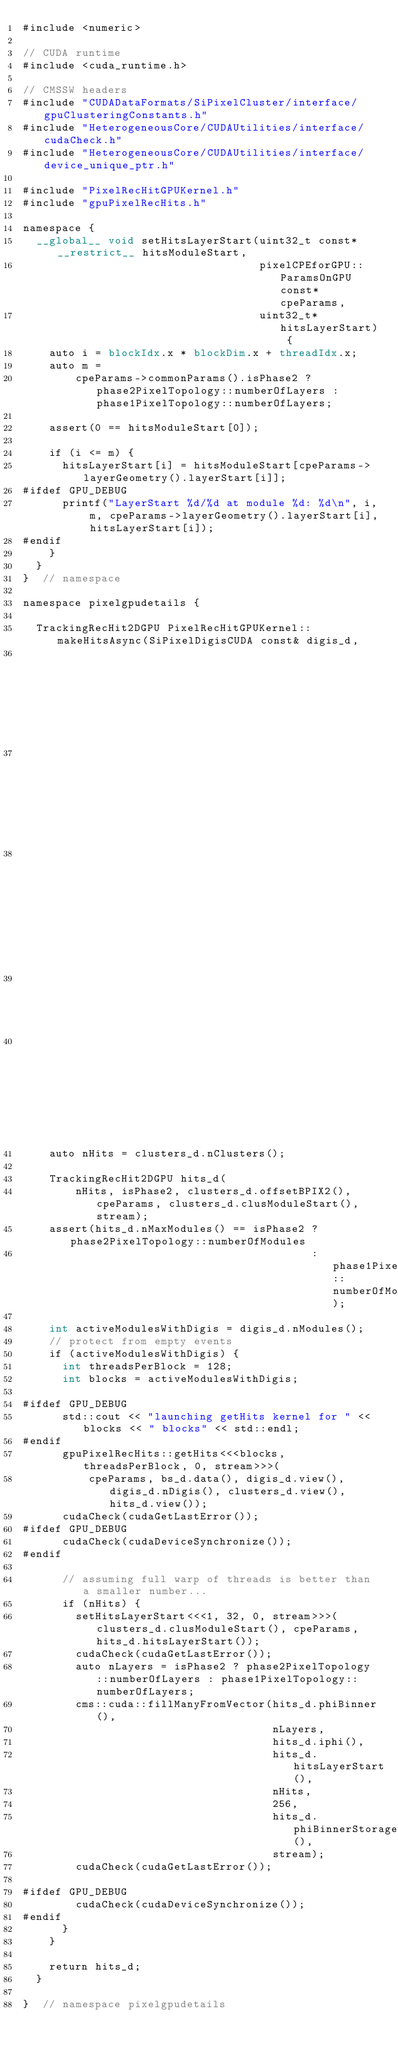<code> <loc_0><loc_0><loc_500><loc_500><_Cuda_>#include <numeric>

// CUDA runtime
#include <cuda_runtime.h>

// CMSSW headers
#include "CUDADataFormats/SiPixelCluster/interface/gpuClusteringConstants.h"
#include "HeterogeneousCore/CUDAUtilities/interface/cudaCheck.h"
#include "HeterogeneousCore/CUDAUtilities/interface/device_unique_ptr.h"

#include "PixelRecHitGPUKernel.h"
#include "gpuPixelRecHits.h"

namespace {
  __global__ void setHitsLayerStart(uint32_t const* __restrict__ hitsModuleStart,
                                    pixelCPEforGPU::ParamsOnGPU const* cpeParams,
                                    uint32_t* hitsLayerStart) {
    auto i = blockIdx.x * blockDim.x + threadIdx.x;
    auto m =
        cpeParams->commonParams().isPhase2 ? phase2PixelTopology::numberOfLayers : phase1PixelTopology::numberOfLayers;

    assert(0 == hitsModuleStart[0]);

    if (i <= m) {
      hitsLayerStart[i] = hitsModuleStart[cpeParams->layerGeometry().layerStart[i]];
#ifdef GPU_DEBUG
      printf("LayerStart %d/%d at module %d: %d\n", i, m, cpeParams->layerGeometry().layerStart[i], hitsLayerStart[i]);
#endif
    }
  }
}  // namespace

namespace pixelgpudetails {

  TrackingRecHit2DGPU PixelRecHitGPUKernel::makeHitsAsync(SiPixelDigisCUDA const& digis_d,
                                                          SiPixelClustersCUDA const& clusters_d,
                                                          BeamSpotCUDA const& bs_d,
                                                          pixelCPEforGPU::ParamsOnGPU const* cpeParams,
                                                          bool isPhase2,
                                                          cudaStream_t stream) const {
    auto nHits = clusters_d.nClusters();

    TrackingRecHit2DGPU hits_d(
        nHits, isPhase2, clusters_d.offsetBPIX2(), cpeParams, clusters_d.clusModuleStart(), stream);
    assert(hits_d.nMaxModules() == isPhase2 ? phase2PixelTopology::numberOfModules
                                            : phase1PixelTopology::numberOfModules);

    int activeModulesWithDigis = digis_d.nModules();
    // protect from empty events
    if (activeModulesWithDigis) {
      int threadsPerBlock = 128;
      int blocks = activeModulesWithDigis;

#ifdef GPU_DEBUG
      std::cout << "launching getHits kernel for " << blocks << " blocks" << std::endl;
#endif
      gpuPixelRecHits::getHits<<<blocks, threadsPerBlock, 0, stream>>>(
          cpeParams, bs_d.data(), digis_d.view(), digis_d.nDigis(), clusters_d.view(), hits_d.view());
      cudaCheck(cudaGetLastError());
#ifdef GPU_DEBUG
      cudaCheck(cudaDeviceSynchronize());
#endif

      // assuming full warp of threads is better than a smaller number...
      if (nHits) {
        setHitsLayerStart<<<1, 32, 0, stream>>>(clusters_d.clusModuleStart(), cpeParams, hits_d.hitsLayerStart());
        cudaCheck(cudaGetLastError());
        auto nLayers = isPhase2 ? phase2PixelTopology::numberOfLayers : phase1PixelTopology::numberOfLayers;
        cms::cuda::fillManyFromVector(hits_d.phiBinner(),
                                      nLayers,
                                      hits_d.iphi(),
                                      hits_d.hitsLayerStart(),
                                      nHits,
                                      256,
                                      hits_d.phiBinnerStorage(),
                                      stream);
        cudaCheck(cudaGetLastError());

#ifdef GPU_DEBUG
        cudaCheck(cudaDeviceSynchronize());
#endif
      }
    }

    return hits_d;
  }

}  // namespace pixelgpudetails
</code> 